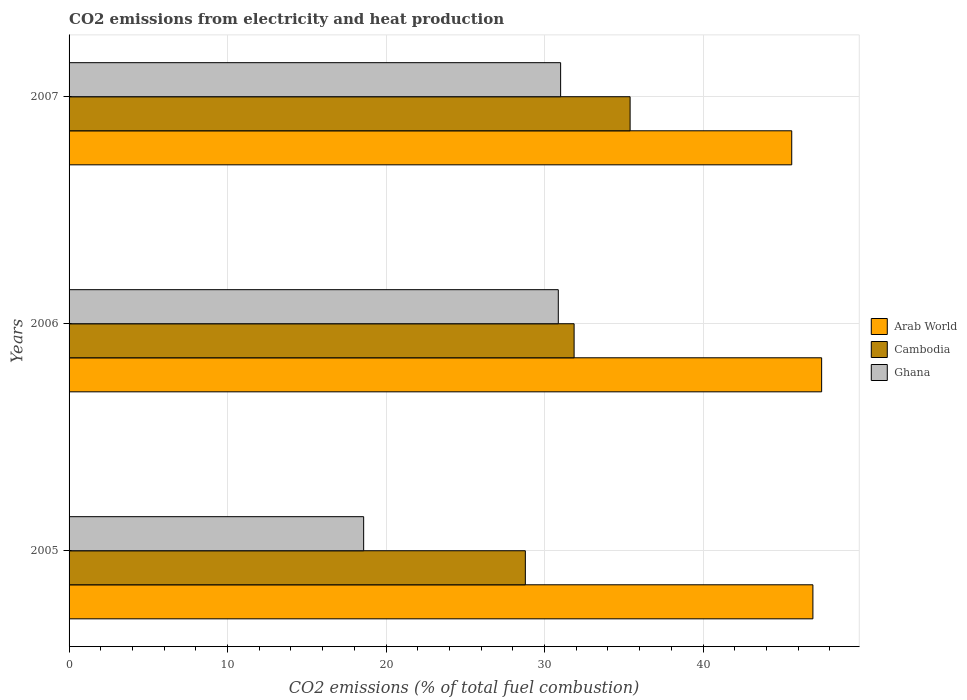How many bars are there on the 3rd tick from the top?
Offer a very short reply. 3. How many bars are there on the 3rd tick from the bottom?
Your answer should be compact. 3. What is the label of the 1st group of bars from the top?
Your response must be concise. 2007. In how many cases, is the number of bars for a given year not equal to the number of legend labels?
Keep it short and to the point. 0. What is the amount of CO2 emitted in Cambodia in 2006?
Ensure brevity in your answer.  31.86. Across all years, what is the maximum amount of CO2 emitted in Cambodia?
Provide a succinct answer. 35.4. Across all years, what is the minimum amount of CO2 emitted in Cambodia?
Offer a terse response. 28.79. What is the total amount of CO2 emitted in Cambodia in the graph?
Keep it short and to the point. 96.05. What is the difference between the amount of CO2 emitted in Ghana in 2006 and that in 2007?
Ensure brevity in your answer.  -0.15. What is the difference between the amount of CO2 emitted in Cambodia in 2005 and the amount of CO2 emitted in Ghana in 2007?
Keep it short and to the point. -2.23. What is the average amount of CO2 emitted in Ghana per year?
Provide a succinct answer. 26.82. In the year 2006, what is the difference between the amount of CO2 emitted in Ghana and amount of CO2 emitted in Cambodia?
Keep it short and to the point. -1. What is the ratio of the amount of CO2 emitted in Ghana in 2005 to that in 2006?
Keep it short and to the point. 0.6. Is the amount of CO2 emitted in Cambodia in 2005 less than that in 2006?
Offer a terse response. Yes. What is the difference between the highest and the second highest amount of CO2 emitted in Ghana?
Ensure brevity in your answer.  0.15. What is the difference between the highest and the lowest amount of CO2 emitted in Arab World?
Your response must be concise. 1.89. In how many years, is the amount of CO2 emitted in Cambodia greater than the average amount of CO2 emitted in Cambodia taken over all years?
Provide a short and direct response. 1. What does the 2nd bar from the top in 2005 represents?
Provide a short and direct response. Cambodia. What does the 1st bar from the bottom in 2005 represents?
Provide a short and direct response. Arab World. Is it the case that in every year, the sum of the amount of CO2 emitted in Cambodia and amount of CO2 emitted in Arab World is greater than the amount of CO2 emitted in Ghana?
Ensure brevity in your answer.  Yes. How many bars are there?
Make the answer very short. 9. Are all the bars in the graph horizontal?
Your response must be concise. Yes. What is the difference between two consecutive major ticks on the X-axis?
Provide a succinct answer. 10. Does the graph contain grids?
Provide a short and direct response. Yes. Where does the legend appear in the graph?
Provide a succinct answer. Center right. What is the title of the graph?
Your response must be concise. CO2 emissions from electricity and heat production. What is the label or title of the X-axis?
Make the answer very short. CO2 emissions (% of total fuel combustion). What is the label or title of the Y-axis?
Keep it short and to the point. Years. What is the CO2 emissions (% of total fuel combustion) of Arab World in 2005?
Make the answer very short. 46.93. What is the CO2 emissions (% of total fuel combustion) of Cambodia in 2005?
Make the answer very short. 28.79. What is the CO2 emissions (% of total fuel combustion) of Ghana in 2005?
Offer a terse response. 18.59. What is the CO2 emissions (% of total fuel combustion) in Arab World in 2006?
Offer a terse response. 47.48. What is the CO2 emissions (% of total fuel combustion) of Cambodia in 2006?
Give a very brief answer. 31.86. What is the CO2 emissions (% of total fuel combustion) in Ghana in 2006?
Provide a short and direct response. 30.87. What is the CO2 emissions (% of total fuel combustion) of Arab World in 2007?
Ensure brevity in your answer.  45.6. What is the CO2 emissions (% of total fuel combustion) of Cambodia in 2007?
Your answer should be compact. 35.4. What is the CO2 emissions (% of total fuel combustion) in Ghana in 2007?
Make the answer very short. 31.01. Across all years, what is the maximum CO2 emissions (% of total fuel combustion) in Arab World?
Your response must be concise. 47.48. Across all years, what is the maximum CO2 emissions (% of total fuel combustion) of Cambodia?
Your response must be concise. 35.4. Across all years, what is the maximum CO2 emissions (% of total fuel combustion) of Ghana?
Give a very brief answer. 31.01. Across all years, what is the minimum CO2 emissions (% of total fuel combustion) in Arab World?
Provide a succinct answer. 45.6. Across all years, what is the minimum CO2 emissions (% of total fuel combustion) of Cambodia?
Provide a short and direct response. 28.79. Across all years, what is the minimum CO2 emissions (% of total fuel combustion) in Ghana?
Your response must be concise. 18.59. What is the total CO2 emissions (% of total fuel combustion) in Arab World in the graph?
Offer a terse response. 140.01. What is the total CO2 emissions (% of total fuel combustion) of Cambodia in the graph?
Keep it short and to the point. 96.05. What is the total CO2 emissions (% of total fuel combustion) in Ghana in the graph?
Your response must be concise. 80.47. What is the difference between the CO2 emissions (% of total fuel combustion) of Arab World in 2005 and that in 2006?
Offer a very short reply. -0.55. What is the difference between the CO2 emissions (% of total fuel combustion) in Cambodia in 2005 and that in 2006?
Keep it short and to the point. -3.08. What is the difference between the CO2 emissions (% of total fuel combustion) in Ghana in 2005 and that in 2006?
Keep it short and to the point. -12.28. What is the difference between the CO2 emissions (% of total fuel combustion) in Arab World in 2005 and that in 2007?
Offer a terse response. 1.34. What is the difference between the CO2 emissions (% of total fuel combustion) of Cambodia in 2005 and that in 2007?
Ensure brevity in your answer.  -6.61. What is the difference between the CO2 emissions (% of total fuel combustion) in Ghana in 2005 and that in 2007?
Your response must be concise. -12.43. What is the difference between the CO2 emissions (% of total fuel combustion) in Arab World in 2006 and that in 2007?
Your answer should be very brief. 1.89. What is the difference between the CO2 emissions (% of total fuel combustion) in Cambodia in 2006 and that in 2007?
Offer a terse response. -3.53. What is the difference between the CO2 emissions (% of total fuel combustion) of Ghana in 2006 and that in 2007?
Provide a short and direct response. -0.15. What is the difference between the CO2 emissions (% of total fuel combustion) in Arab World in 2005 and the CO2 emissions (% of total fuel combustion) in Cambodia in 2006?
Provide a short and direct response. 15.07. What is the difference between the CO2 emissions (% of total fuel combustion) in Arab World in 2005 and the CO2 emissions (% of total fuel combustion) in Ghana in 2006?
Give a very brief answer. 16.06. What is the difference between the CO2 emissions (% of total fuel combustion) of Cambodia in 2005 and the CO2 emissions (% of total fuel combustion) of Ghana in 2006?
Make the answer very short. -2.08. What is the difference between the CO2 emissions (% of total fuel combustion) of Arab World in 2005 and the CO2 emissions (% of total fuel combustion) of Cambodia in 2007?
Offer a very short reply. 11.53. What is the difference between the CO2 emissions (% of total fuel combustion) of Arab World in 2005 and the CO2 emissions (% of total fuel combustion) of Ghana in 2007?
Offer a terse response. 15.92. What is the difference between the CO2 emissions (% of total fuel combustion) of Cambodia in 2005 and the CO2 emissions (% of total fuel combustion) of Ghana in 2007?
Keep it short and to the point. -2.23. What is the difference between the CO2 emissions (% of total fuel combustion) in Arab World in 2006 and the CO2 emissions (% of total fuel combustion) in Cambodia in 2007?
Make the answer very short. 12.08. What is the difference between the CO2 emissions (% of total fuel combustion) in Arab World in 2006 and the CO2 emissions (% of total fuel combustion) in Ghana in 2007?
Your response must be concise. 16.47. What is the difference between the CO2 emissions (% of total fuel combustion) of Cambodia in 2006 and the CO2 emissions (% of total fuel combustion) of Ghana in 2007?
Keep it short and to the point. 0.85. What is the average CO2 emissions (% of total fuel combustion) in Arab World per year?
Ensure brevity in your answer.  46.67. What is the average CO2 emissions (% of total fuel combustion) of Cambodia per year?
Make the answer very short. 32.02. What is the average CO2 emissions (% of total fuel combustion) in Ghana per year?
Keep it short and to the point. 26.82. In the year 2005, what is the difference between the CO2 emissions (% of total fuel combustion) in Arab World and CO2 emissions (% of total fuel combustion) in Cambodia?
Your answer should be compact. 18.14. In the year 2005, what is the difference between the CO2 emissions (% of total fuel combustion) in Arab World and CO2 emissions (% of total fuel combustion) in Ghana?
Offer a very short reply. 28.34. In the year 2005, what is the difference between the CO2 emissions (% of total fuel combustion) in Cambodia and CO2 emissions (% of total fuel combustion) in Ghana?
Make the answer very short. 10.2. In the year 2006, what is the difference between the CO2 emissions (% of total fuel combustion) of Arab World and CO2 emissions (% of total fuel combustion) of Cambodia?
Your answer should be very brief. 15.62. In the year 2006, what is the difference between the CO2 emissions (% of total fuel combustion) in Arab World and CO2 emissions (% of total fuel combustion) in Ghana?
Provide a succinct answer. 16.62. In the year 2007, what is the difference between the CO2 emissions (% of total fuel combustion) of Arab World and CO2 emissions (% of total fuel combustion) of Cambodia?
Make the answer very short. 10.2. In the year 2007, what is the difference between the CO2 emissions (% of total fuel combustion) in Arab World and CO2 emissions (% of total fuel combustion) in Ghana?
Your answer should be very brief. 14.58. In the year 2007, what is the difference between the CO2 emissions (% of total fuel combustion) in Cambodia and CO2 emissions (% of total fuel combustion) in Ghana?
Provide a short and direct response. 4.38. What is the ratio of the CO2 emissions (% of total fuel combustion) in Arab World in 2005 to that in 2006?
Make the answer very short. 0.99. What is the ratio of the CO2 emissions (% of total fuel combustion) of Cambodia in 2005 to that in 2006?
Provide a short and direct response. 0.9. What is the ratio of the CO2 emissions (% of total fuel combustion) of Ghana in 2005 to that in 2006?
Offer a very short reply. 0.6. What is the ratio of the CO2 emissions (% of total fuel combustion) of Arab World in 2005 to that in 2007?
Provide a succinct answer. 1.03. What is the ratio of the CO2 emissions (% of total fuel combustion) in Cambodia in 2005 to that in 2007?
Offer a terse response. 0.81. What is the ratio of the CO2 emissions (% of total fuel combustion) in Ghana in 2005 to that in 2007?
Your answer should be very brief. 0.6. What is the ratio of the CO2 emissions (% of total fuel combustion) of Arab World in 2006 to that in 2007?
Your answer should be compact. 1.04. What is the ratio of the CO2 emissions (% of total fuel combustion) of Cambodia in 2006 to that in 2007?
Offer a terse response. 0.9. What is the difference between the highest and the second highest CO2 emissions (% of total fuel combustion) of Arab World?
Provide a short and direct response. 0.55. What is the difference between the highest and the second highest CO2 emissions (% of total fuel combustion) in Cambodia?
Your answer should be very brief. 3.53. What is the difference between the highest and the second highest CO2 emissions (% of total fuel combustion) in Ghana?
Provide a succinct answer. 0.15. What is the difference between the highest and the lowest CO2 emissions (% of total fuel combustion) of Arab World?
Your response must be concise. 1.89. What is the difference between the highest and the lowest CO2 emissions (% of total fuel combustion) in Cambodia?
Offer a very short reply. 6.61. What is the difference between the highest and the lowest CO2 emissions (% of total fuel combustion) in Ghana?
Keep it short and to the point. 12.43. 